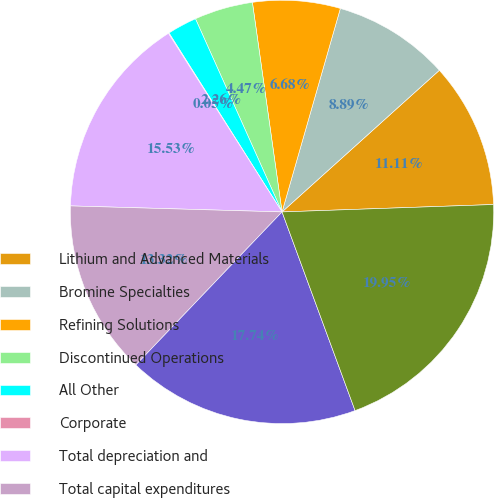<chart> <loc_0><loc_0><loc_500><loc_500><pie_chart><fcel>Lithium and Advanced Materials<fcel>Bromine Specialties<fcel>Refining Solutions<fcel>Discontinued Operations<fcel>All Other<fcel>Corporate<fcel>Total depreciation and<fcel>Total capital expenditures<fcel>United States<fcel>Foreign^(a)<nl><fcel>11.11%<fcel>8.89%<fcel>6.68%<fcel>4.47%<fcel>2.26%<fcel>0.05%<fcel>15.53%<fcel>13.32%<fcel>17.74%<fcel>19.95%<nl></chart> 